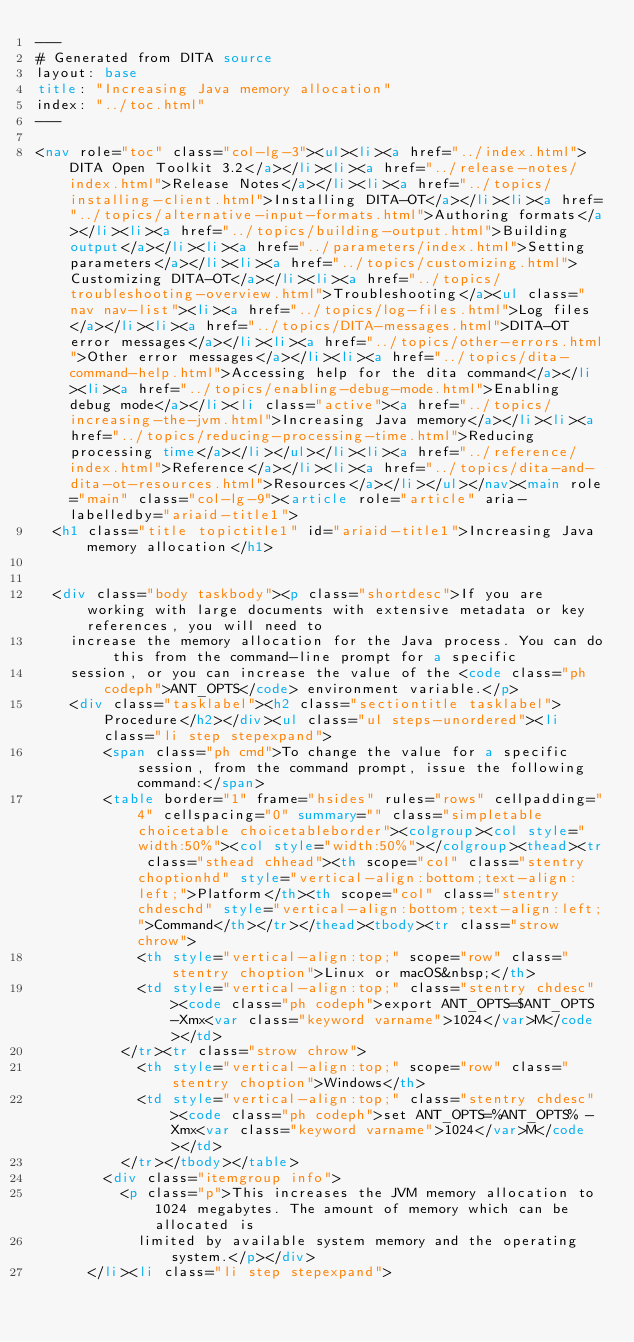<code> <loc_0><loc_0><loc_500><loc_500><_HTML_>---
# Generated from DITA source
layout: base
title: "Increasing Java memory allocation"
index: "../toc.html"
---

<nav role="toc" class="col-lg-3"><ul><li><a href="../index.html">DITA Open Toolkit 3.2</a></li><li><a href="../release-notes/index.html">Release Notes</a></li><li><a href="../topics/installing-client.html">Installing DITA-OT</a></li><li><a href="../topics/alternative-input-formats.html">Authoring formats</a></li><li><a href="../topics/building-output.html">Building output</a></li><li><a href="../parameters/index.html">Setting parameters</a></li><li><a href="../topics/customizing.html">Customizing DITA-OT</a></li><li><a href="../topics/troubleshooting-overview.html">Troubleshooting</a><ul class="nav nav-list"><li><a href="../topics/log-files.html">Log files</a></li><li><a href="../topics/DITA-messages.html">DITA-OT error messages</a></li><li><a href="../topics/other-errors.html">Other error messages</a></li><li><a href="../topics/dita-command-help.html">Accessing help for the dita command</a></li><li><a href="../topics/enabling-debug-mode.html">Enabling debug mode</a></li><li class="active"><a href="../topics/increasing-the-jvm.html">Increasing Java memory</a></li><li><a href="../topics/reducing-processing-time.html">Reducing processing time</a></li></ul></li><li><a href="../reference/index.html">Reference</a></li><li><a href="../topics/dita-and-dita-ot-resources.html">Resources</a></li></ul></nav><main role="main" class="col-lg-9"><article role="article" aria-labelledby="ariaid-title1">
  <h1 class="title topictitle1" id="ariaid-title1">Increasing Java memory allocation</h1>
  
  
  <div class="body taskbody"><p class="shortdesc">If you are working with large documents with extensive metadata or key references, you will need to
    increase the memory allocation for the Java process. You can do this from the command-line prompt for a specific
    session, or you can increase the value of the <code class="ph codeph">ANT_OPTS</code> environment variable.</p>
    <div class="tasklabel"><h2 class="sectiontitle tasklabel">Procedure</h2></div><ul class="ul steps-unordered"><li class="li step stepexpand">
        <span class="ph cmd">To change the value for a specific session, from the command prompt, issue the following command:</span>
        <table border="1" frame="hsides" rules="rows" cellpadding="4" cellspacing="0" summary="" class="simpletable choicetable choicetableborder"><colgroup><col style="width:50%"><col style="width:50%"></colgroup><thead><tr class="sthead chhead"><th scope="col" class="stentry choptionhd" style="vertical-align:bottom;text-align:left;">Platform</th><th scope="col" class="stentry chdeschd" style="vertical-align:bottom;text-align:left;">Command</th></tr></thead><tbody><tr class="strow chrow">
            <th style="vertical-align:top;" scope="row" class="stentry choption">Linux or macOS&nbsp;</th>
            <td style="vertical-align:top;" class="stentry chdesc"><code class="ph codeph">export ANT_OPTS=$ANT_OPTS -Xmx<var class="keyword varname">1024</var>M</code></td>
          </tr><tr class="strow chrow">
            <th style="vertical-align:top;" scope="row" class="stentry choption">Windows</th>
            <td style="vertical-align:top;" class="stentry chdesc"><code class="ph codeph">set ANT_OPTS=%ANT_OPTS% -Xmx<var class="keyword varname">1024</var>M</code></td>
          </tr></tbody></table>
        <div class="itemgroup info">
          <p class="p">This increases the JVM memory allocation to 1024 megabytes. The amount of memory which can be allocated is
            limited by available system memory and the operating system.</p></div>
      </li><li class="li step stepexpand"></code> 